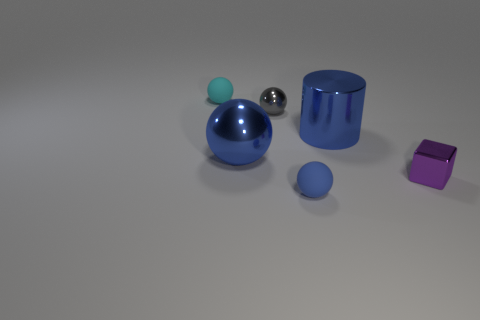There is a shiny object that is both on the right side of the gray ball and on the left side of the tiny purple metallic object; what size is it?
Give a very brief answer. Large. What number of cyan balls are made of the same material as the tiny purple thing?
Provide a short and direct response. 0. How many blocks are small purple things or blue matte things?
Offer a terse response. 1. What is the size of the rubber sphere that is to the left of the small matte ball that is right of the small rubber ball behind the small shiny ball?
Keep it short and to the point. Small. The small object that is both to the right of the big blue metallic ball and behind the blue cylinder is what color?
Provide a succinct answer. Gray. Is the size of the metal cylinder the same as the thing that is behind the tiny gray metallic thing?
Your answer should be compact. No. Are there any other things that have the same shape as the purple object?
Provide a succinct answer. No. What color is the other big metallic object that is the same shape as the gray metal thing?
Provide a short and direct response. Blue. Is the size of the purple thing the same as the gray ball?
Offer a terse response. Yes. How many other objects are the same size as the blue rubber sphere?
Offer a very short reply. 3. 